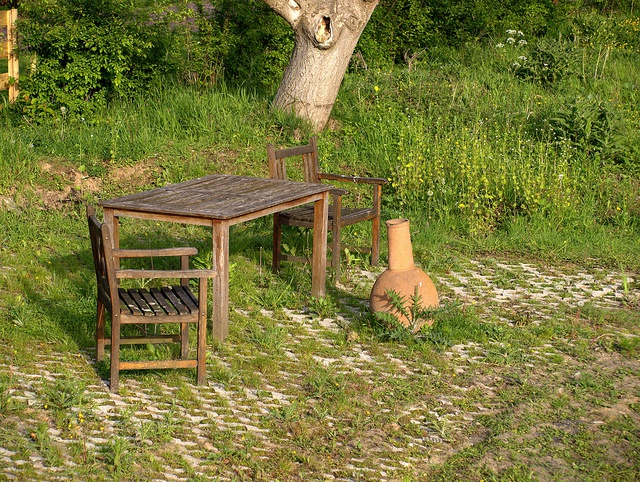Describe the objects in this image and their specific colors. I can see chair in black, olive, gray, and tan tones, dining table in black, gray, tan, and olive tones, chair in black, olive, and gray tones, and vase in black, tan, and gray tones in this image. 